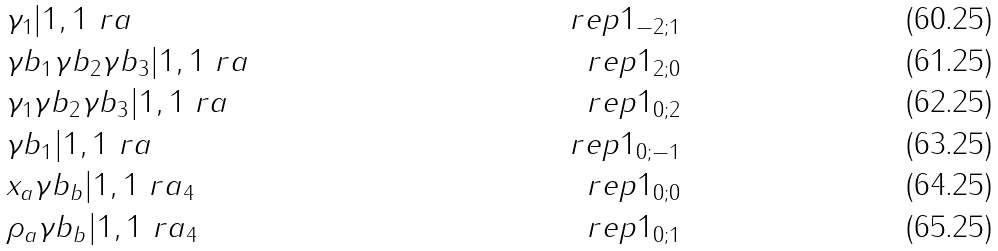Convert formula to latex. <formula><loc_0><loc_0><loc_500><loc_500>& \gamma _ { 1 } | 1 , 1 \ r a & \ r e p { 1 } _ { - 2 ; 1 } \\ & \gamma b _ { 1 } \gamma b _ { 2 } \gamma b _ { 3 } | 1 , 1 \ r a & \ r e p { 1 } _ { 2 ; 0 } \\ & \gamma _ { 1 } \gamma b _ { 2 } \gamma b _ { 3 } | 1 , 1 \ r a & \ r e p { 1 } _ { 0 ; 2 } \\ & \gamma b _ { 1 } | 1 , 1 \ r a & \ r e p { 1 } _ { 0 ; - 1 } \\ & x _ { a } \gamma b _ { b } | 1 , 1 \ r a _ { 4 } & \ r e p { 1 } _ { 0 ; 0 } \\ & \rho _ { a } \gamma b _ { b } | 1 , 1 \ r a _ { 4 } & \ r e p { 1 } _ { 0 ; 1 }</formula> 